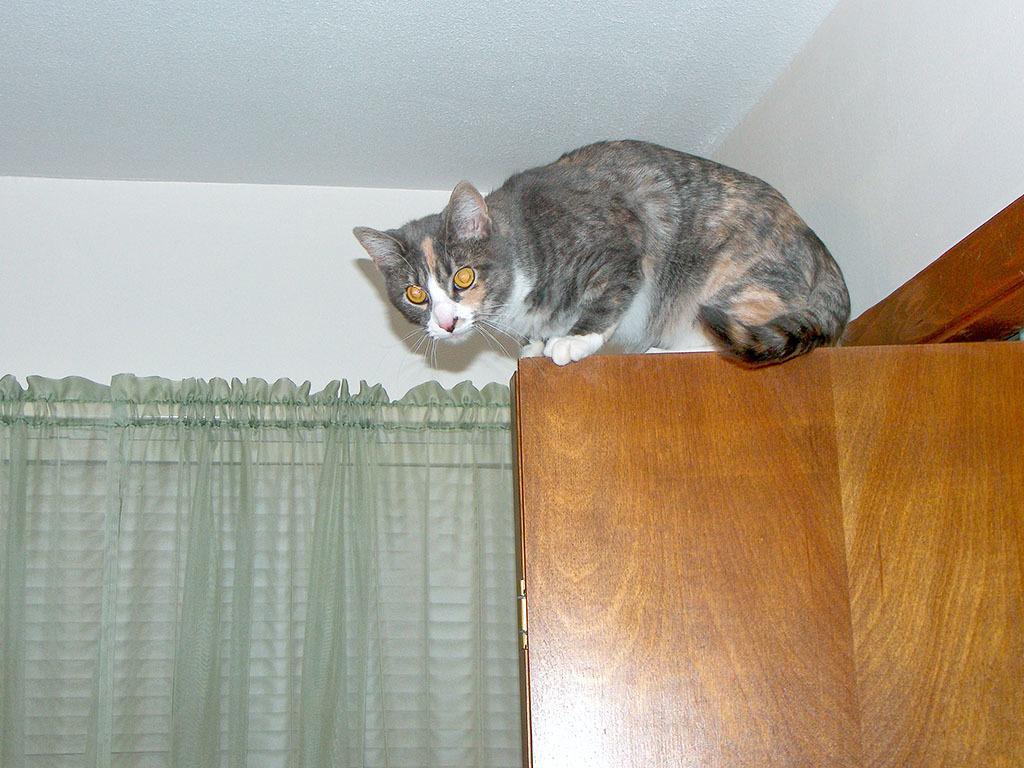Could you give a brief overview of what you see in this image? There is one cat present on the door as we can see on the right side of this image. There is a curtain on the left side of this image and there is a wall in the background. 